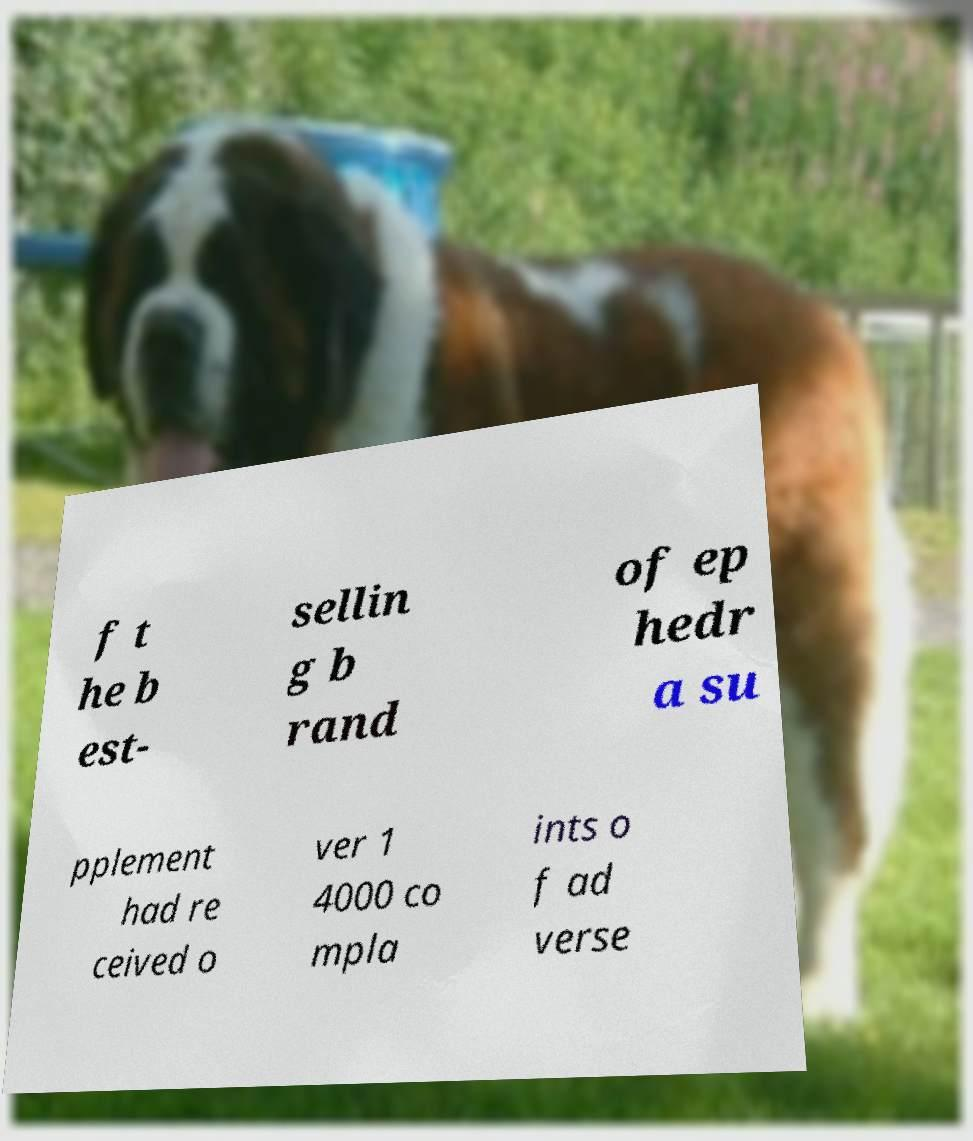Could you extract and type out the text from this image? f t he b est- sellin g b rand of ep hedr a su pplement had re ceived o ver 1 4000 co mpla ints o f ad verse 